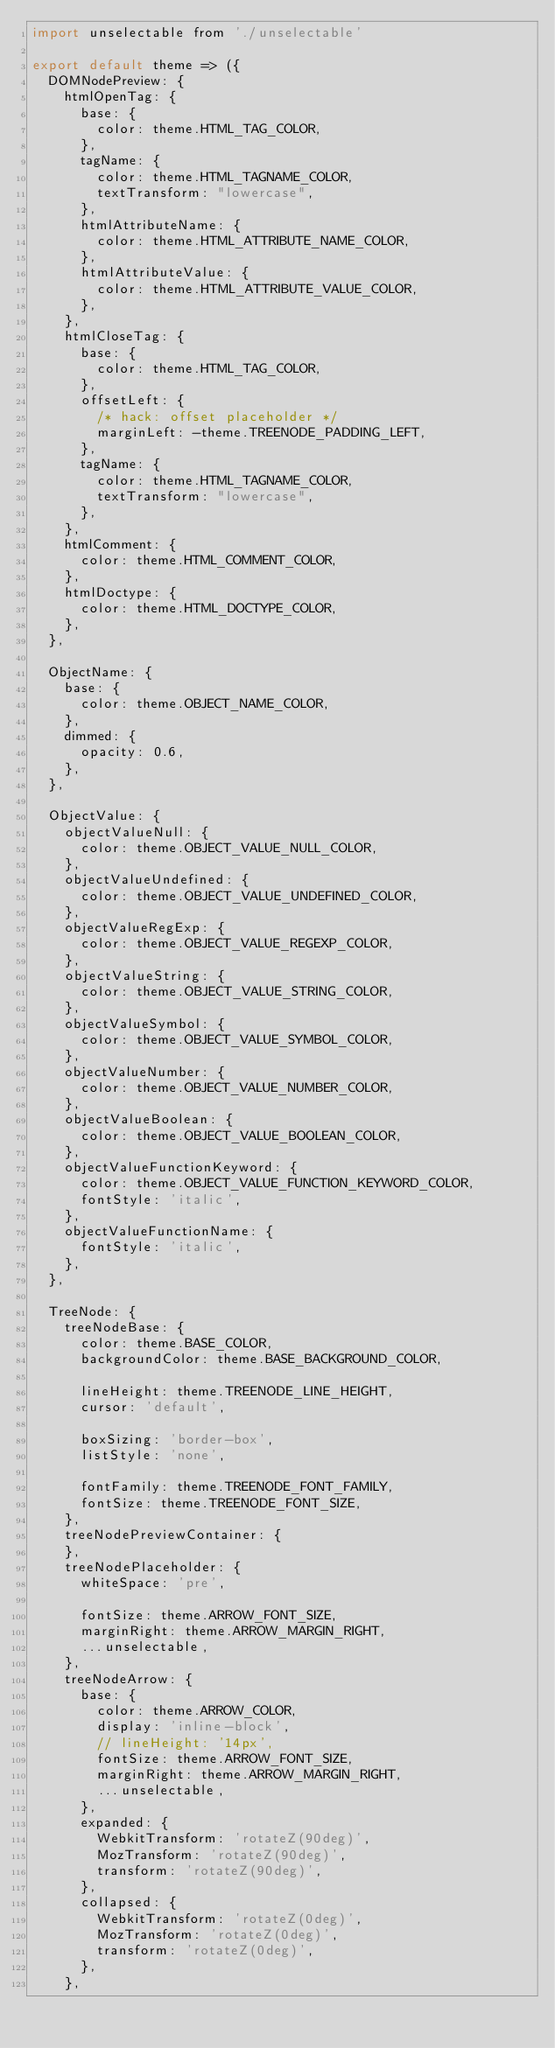<code> <loc_0><loc_0><loc_500><loc_500><_JavaScript_>import unselectable from './unselectable'

export default theme => ({
  DOMNodePreview: {
    htmlOpenTag: {
      base: {
        color: theme.HTML_TAG_COLOR,
      },
      tagName: {
        color: theme.HTML_TAGNAME_COLOR,
        textTransform: "lowercase",
      },
      htmlAttributeName: {
        color: theme.HTML_ATTRIBUTE_NAME_COLOR,
      },
      htmlAttributeValue: {
        color: theme.HTML_ATTRIBUTE_VALUE_COLOR,
      },
    },
    htmlCloseTag: {
      base: {
        color: theme.HTML_TAG_COLOR,
      },
      offsetLeft: {
        /* hack: offset placeholder */
        marginLeft: -theme.TREENODE_PADDING_LEFT,
      },
      tagName: {
        color: theme.HTML_TAGNAME_COLOR,
        textTransform: "lowercase",
      },
    },
    htmlComment: {
      color: theme.HTML_COMMENT_COLOR,
    },
    htmlDoctype: {
      color: theme.HTML_DOCTYPE_COLOR,
    },
  },

  ObjectName: {
    base: {
      color: theme.OBJECT_NAME_COLOR,
    },
    dimmed: {
      opacity: 0.6,
    },
  },

  ObjectValue: {
    objectValueNull: {
      color: theme.OBJECT_VALUE_NULL_COLOR,
    },
    objectValueUndefined: {
      color: theme.OBJECT_VALUE_UNDEFINED_COLOR,
    },
    objectValueRegExp: {
      color: theme.OBJECT_VALUE_REGEXP_COLOR,
    },
    objectValueString: {
      color: theme.OBJECT_VALUE_STRING_COLOR,
    },
    objectValueSymbol: {
      color: theme.OBJECT_VALUE_SYMBOL_COLOR,
    },
    objectValueNumber: {
      color: theme.OBJECT_VALUE_NUMBER_COLOR,
    },
    objectValueBoolean: {
      color: theme.OBJECT_VALUE_BOOLEAN_COLOR,
    },
    objectValueFunctionKeyword: {
      color: theme.OBJECT_VALUE_FUNCTION_KEYWORD_COLOR,
      fontStyle: 'italic',
    },
    objectValueFunctionName: {
      fontStyle: 'italic',
    },
  },

  TreeNode: {
    treeNodeBase: {
      color: theme.BASE_COLOR,
      backgroundColor: theme.BASE_BACKGROUND_COLOR,

      lineHeight: theme.TREENODE_LINE_HEIGHT,
      cursor: 'default',

      boxSizing: 'border-box',
      listStyle: 'none',

      fontFamily: theme.TREENODE_FONT_FAMILY,
      fontSize: theme.TREENODE_FONT_SIZE,
    },
    treeNodePreviewContainer: {
    },
    treeNodePlaceholder: {
      whiteSpace: 'pre',

      fontSize: theme.ARROW_FONT_SIZE,
      marginRight: theme.ARROW_MARGIN_RIGHT,
      ...unselectable,
    },
    treeNodeArrow: {
      base: {
        color: theme.ARROW_COLOR,
        display: 'inline-block',
        // lineHeight: '14px',
        fontSize: theme.ARROW_FONT_SIZE,
        marginRight: theme.ARROW_MARGIN_RIGHT,
        ...unselectable,
      },
      expanded: {
        WebkitTransform: 'rotateZ(90deg)',
        MozTransform: 'rotateZ(90deg)',
        transform: 'rotateZ(90deg)',
      },
      collapsed: {
        WebkitTransform: 'rotateZ(0deg)',
        MozTransform: 'rotateZ(0deg)',
        transform: 'rotateZ(0deg)',
      },
    },</code> 